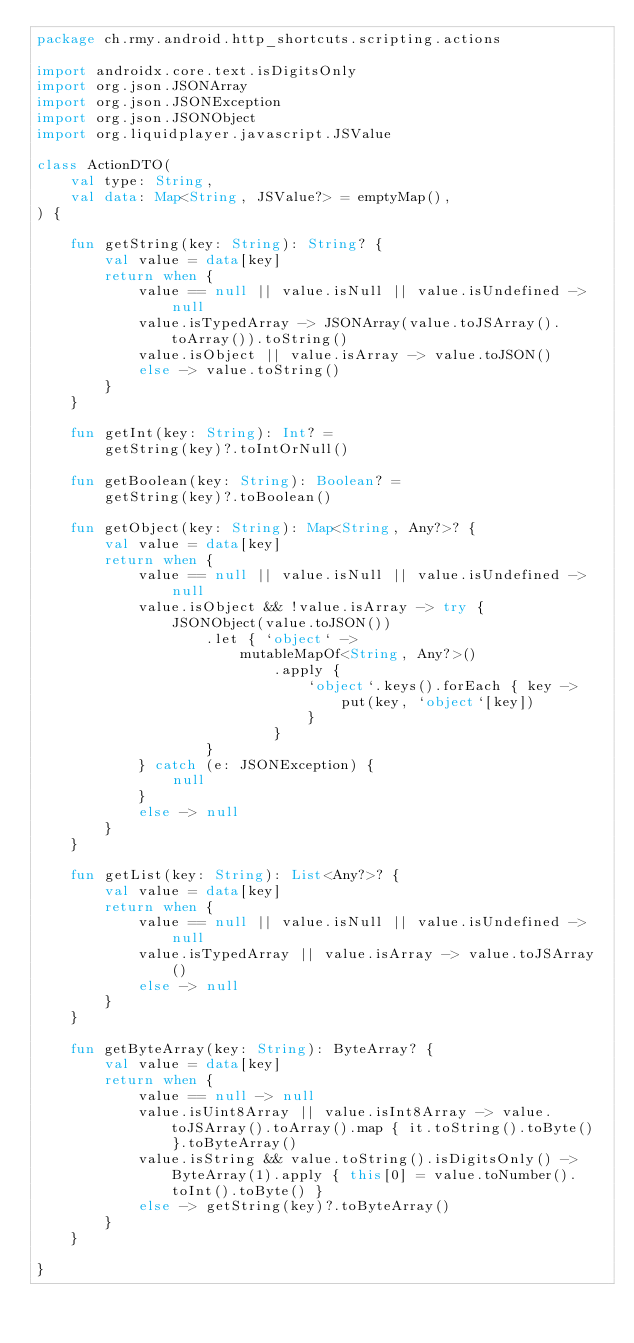Convert code to text. <code><loc_0><loc_0><loc_500><loc_500><_Kotlin_>package ch.rmy.android.http_shortcuts.scripting.actions

import androidx.core.text.isDigitsOnly
import org.json.JSONArray
import org.json.JSONException
import org.json.JSONObject
import org.liquidplayer.javascript.JSValue

class ActionDTO(
    val type: String,
    val data: Map<String, JSValue?> = emptyMap(),
) {

    fun getString(key: String): String? {
        val value = data[key]
        return when {
            value == null || value.isNull || value.isUndefined -> null
            value.isTypedArray -> JSONArray(value.toJSArray().toArray()).toString()
            value.isObject || value.isArray -> value.toJSON()
            else -> value.toString()
        }
    }

    fun getInt(key: String): Int? =
        getString(key)?.toIntOrNull()

    fun getBoolean(key: String): Boolean? =
        getString(key)?.toBoolean()

    fun getObject(key: String): Map<String, Any?>? {
        val value = data[key]
        return when {
            value == null || value.isNull || value.isUndefined -> null
            value.isObject && !value.isArray -> try {
                JSONObject(value.toJSON())
                    .let { `object` ->
                        mutableMapOf<String, Any?>()
                            .apply {
                                `object`.keys().forEach { key ->
                                    put(key, `object`[key])
                                }
                            }
                    }
            } catch (e: JSONException) {
                null
            }
            else -> null
        }
    }

    fun getList(key: String): List<Any?>? {
        val value = data[key]
        return when {
            value == null || value.isNull || value.isUndefined -> null
            value.isTypedArray || value.isArray -> value.toJSArray()
            else -> null
        }
    }

    fun getByteArray(key: String): ByteArray? {
        val value = data[key]
        return when {
            value == null -> null
            value.isUint8Array || value.isInt8Array -> value.toJSArray().toArray().map { it.toString().toByte() }.toByteArray()
            value.isString && value.toString().isDigitsOnly() -> ByteArray(1).apply { this[0] = value.toNumber().toInt().toByte() }
            else -> getString(key)?.toByteArray()
        }
    }

}
</code> 